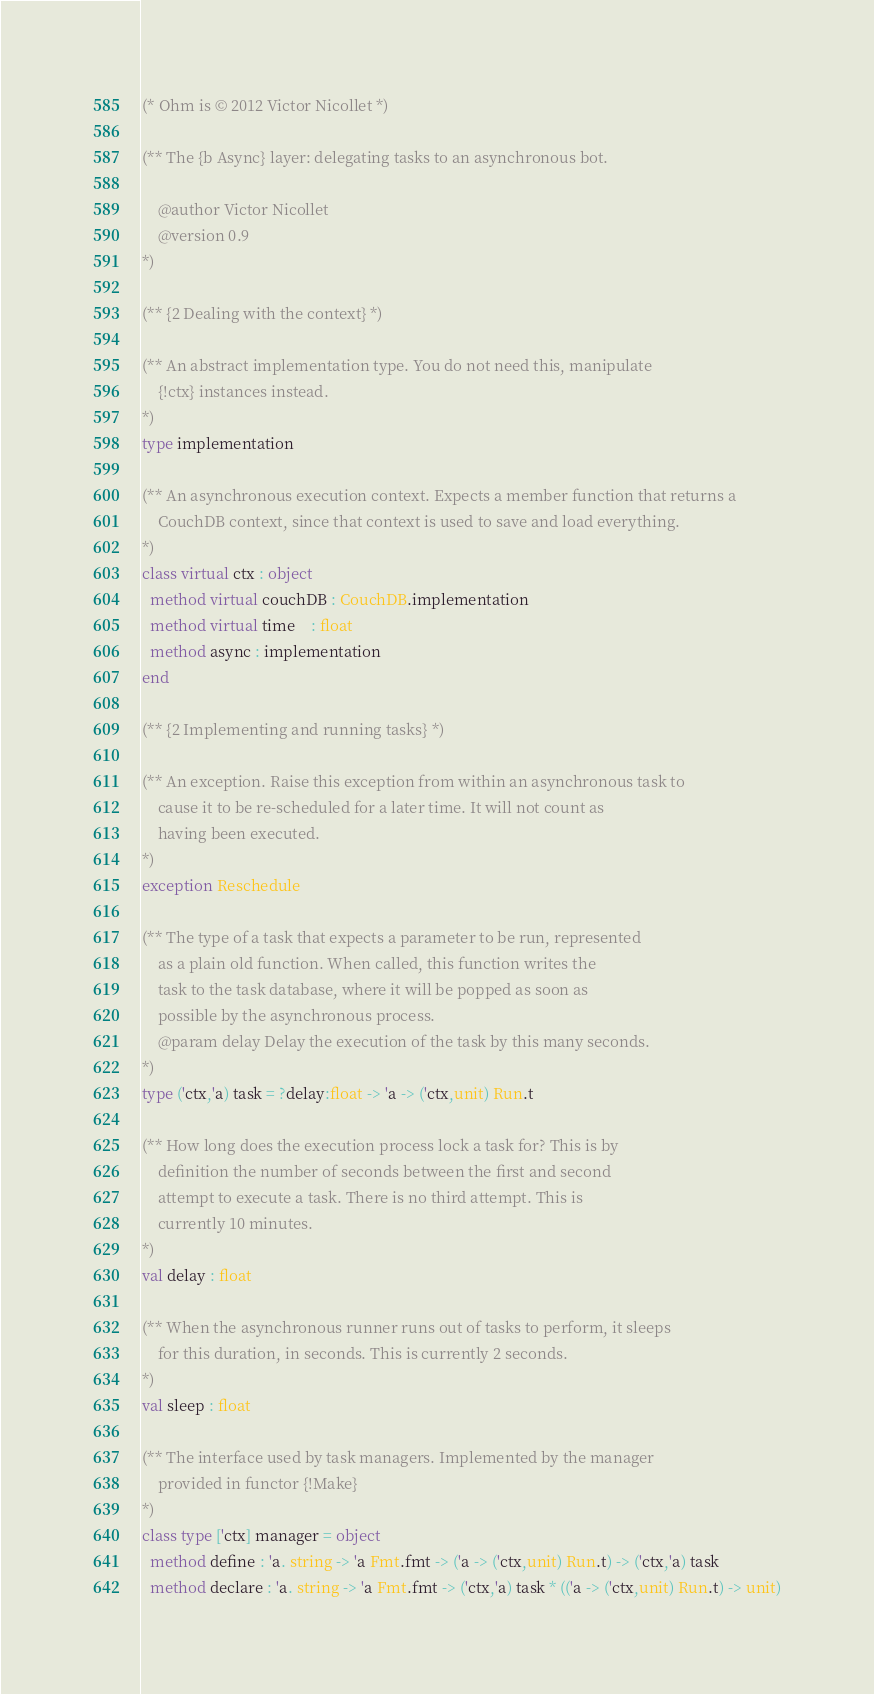<code> <loc_0><loc_0><loc_500><loc_500><_OCaml_>(* Ohm is © 2012 Victor Nicollet *)

(** The {b Async} layer: delegating tasks to an asynchronous bot.

    @author Victor Nicollet
    @version 0.9
*)

(** {2 Dealing with the context} *)

(** An abstract implementation type. You do not need this, manipulate 
    {!ctx} instances instead. 
*)
type implementation 

(** An asynchronous execution context. Expects a member function that returns a
    CouchDB context, since that context is used to save and load everything. 
*)
class virtual ctx : object
  method virtual couchDB : CouchDB.implementation
  method virtual time    : float
  method async : implementation
end

(** {2 Implementing and running tasks} *)

(** An exception. Raise this exception from within an asynchronous task to
    cause it to be re-scheduled for a later time. It will not count as 
    having been executed. 
*)
exception Reschedule

(** The type of a task that expects a parameter to be run, represented
    as a plain old function. When called, this function writes the 
    task to the task database, where it will be popped as soon as 
    possible by the asynchronous process. 
    @param delay Delay the execution of the task by this many seconds. 
*)
type ('ctx,'a) task = ?delay:float -> 'a -> ('ctx,unit) Run.t

(** How long does the execution process lock a task for? This is by 
    definition the number of seconds between the first and second
    attempt to execute a task. There is no third attempt. This is
    currently 10 minutes. 
*)
val delay : float

(** When the asynchronous runner runs out of tasks to perform, it sleeps
    for this duration, in seconds. This is currently 2 seconds.
*)
val sleep : float

(** The interface used by task managers. Implemented by the manager 
    provided in functor {!Make} 
*)
class type ['ctx] manager = object
  method define : 'a. string -> 'a Fmt.fmt -> ('a -> ('ctx,unit) Run.t) -> ('ctx,'a) task
  method declare : 'a. string -> 'a Fmt.fmt -> ('ctx,'a) task * (('a -> ('ctx,unit) Run.t) -> unit)</code> 